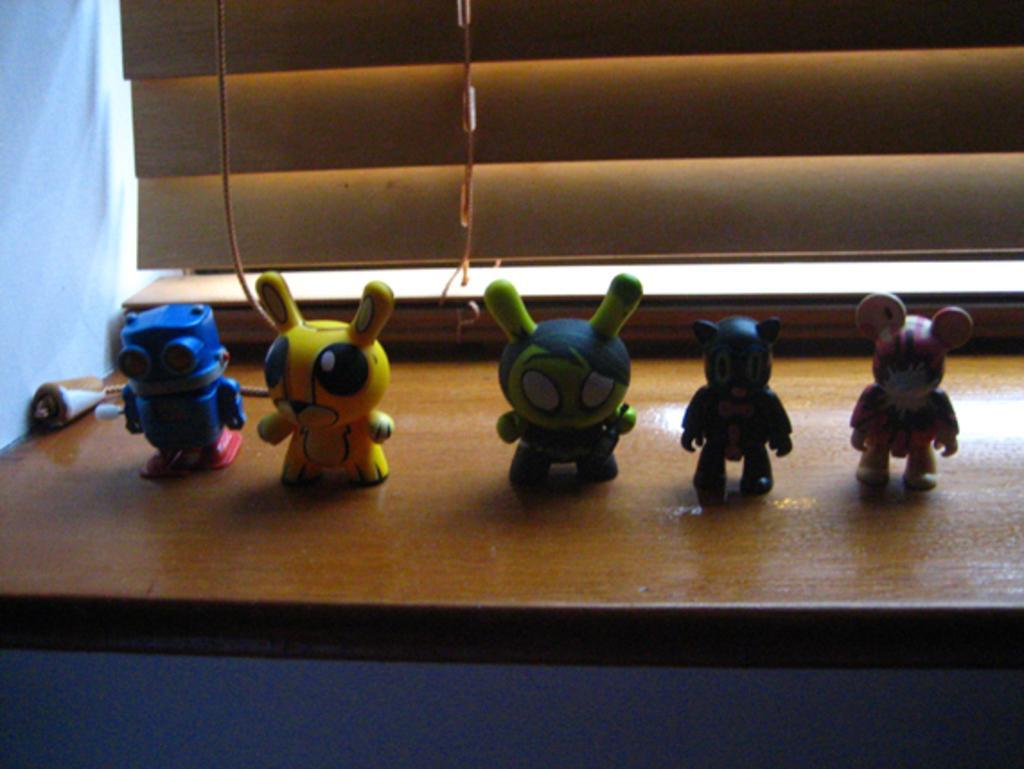In one or two sentences, can you explain what this image depicts? In this picture there are toys in the center of the image, on a desk, there is a window at the top side of the image. 